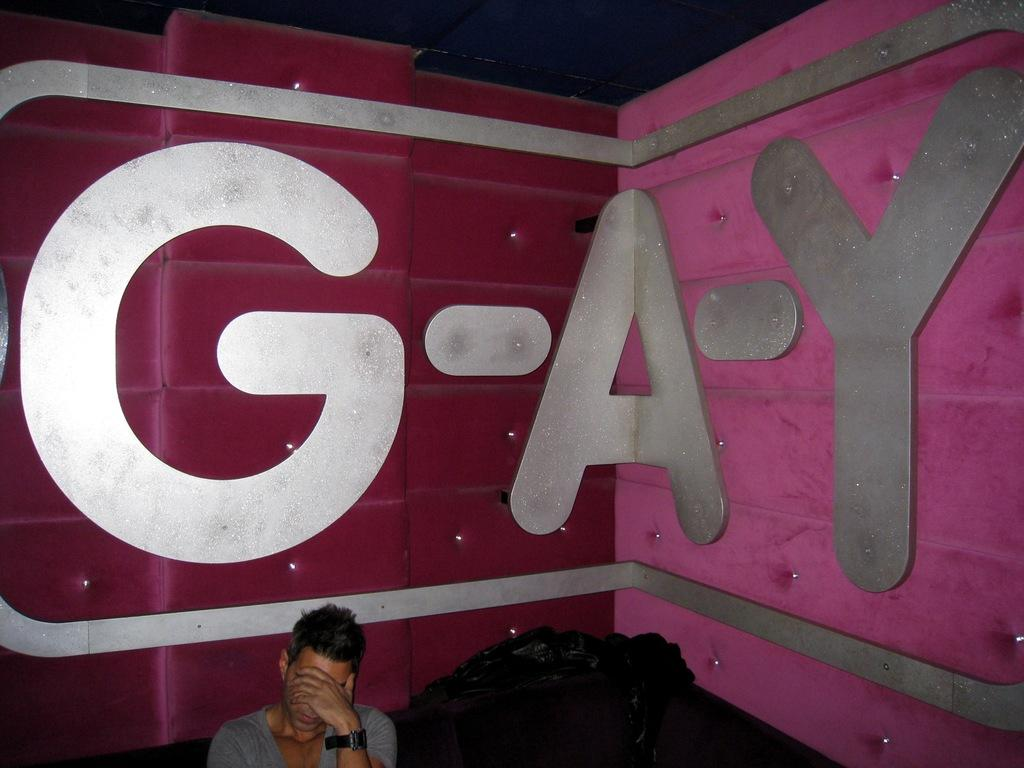What is the position of the man in the image? The man is sitting at the bottom of the image. What objects are near the man? There are covers beside the man. What can be seen in the background of the image? There is a wall in the background of the image. What is written on the wall? There is text written on the wall. What type of salt is sprinkled on the man's head in the image? There is no salt present in the image; the man is simply sitting with covers beside him. 